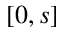Convert formula to latex. <formula><loc_0><loc_0><loc_500><loc_500>[ 0 , s ]</formula> 